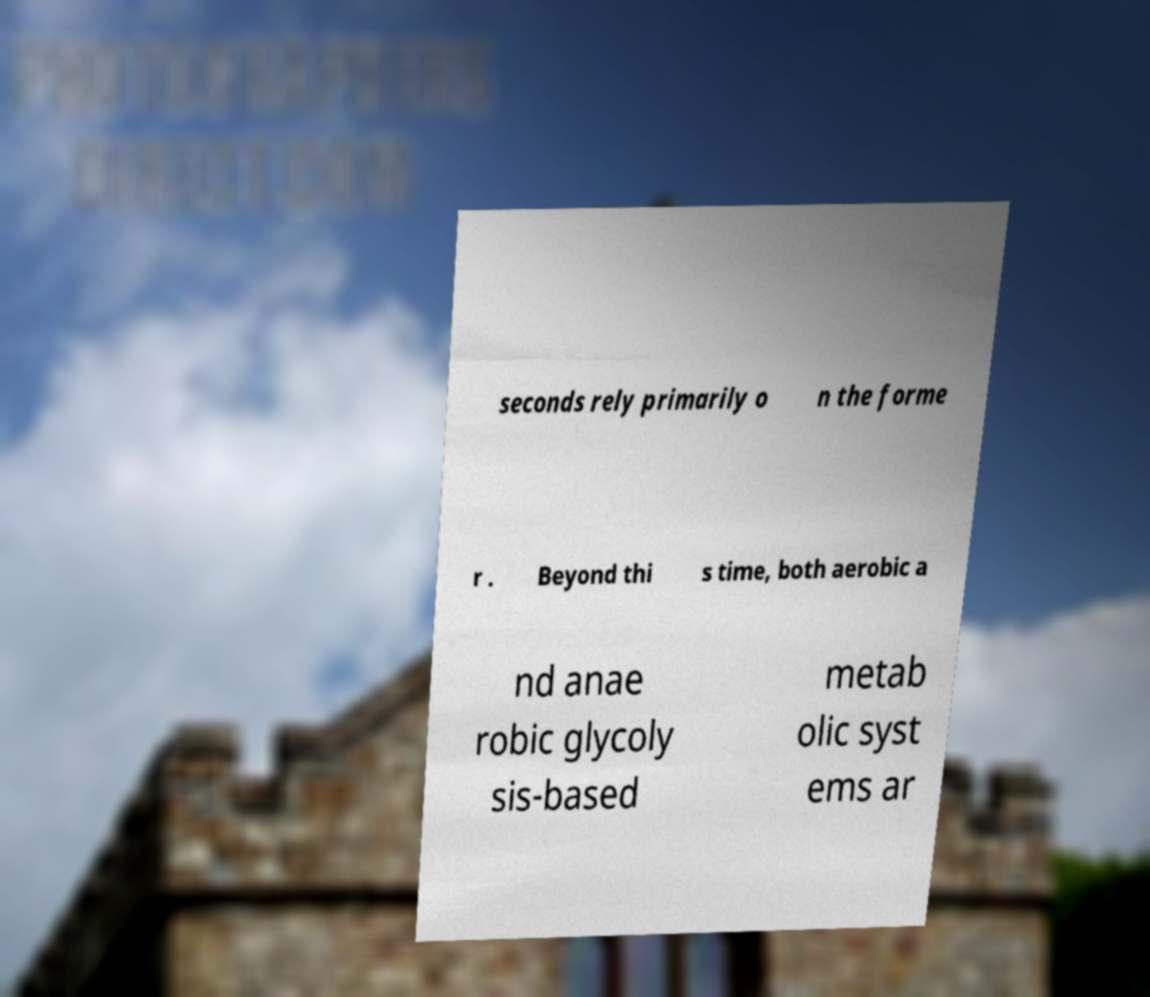Could you assist in decoding the text presented in this image and type it out clearly? seconds rely primarily o n the forme r . Beyond thi s time, both aerobic a nd anae robic glycoly sis-based metab olic syst ems ar 